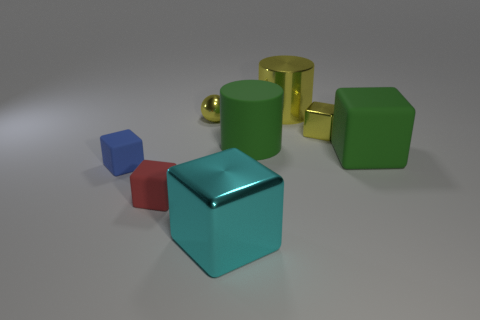Can you describe the shapes and colors present in this image? Certainly! The image showcases a variety of geometric shapes in various colors. There is a cyan colored cube, a small red cube, and a small blue cube. Additionally, there are three cylinders: two of them are green and one is yellow, all of which are larger than the cubes. The colors are vibrant and create a striking contrast against the neutral background. 